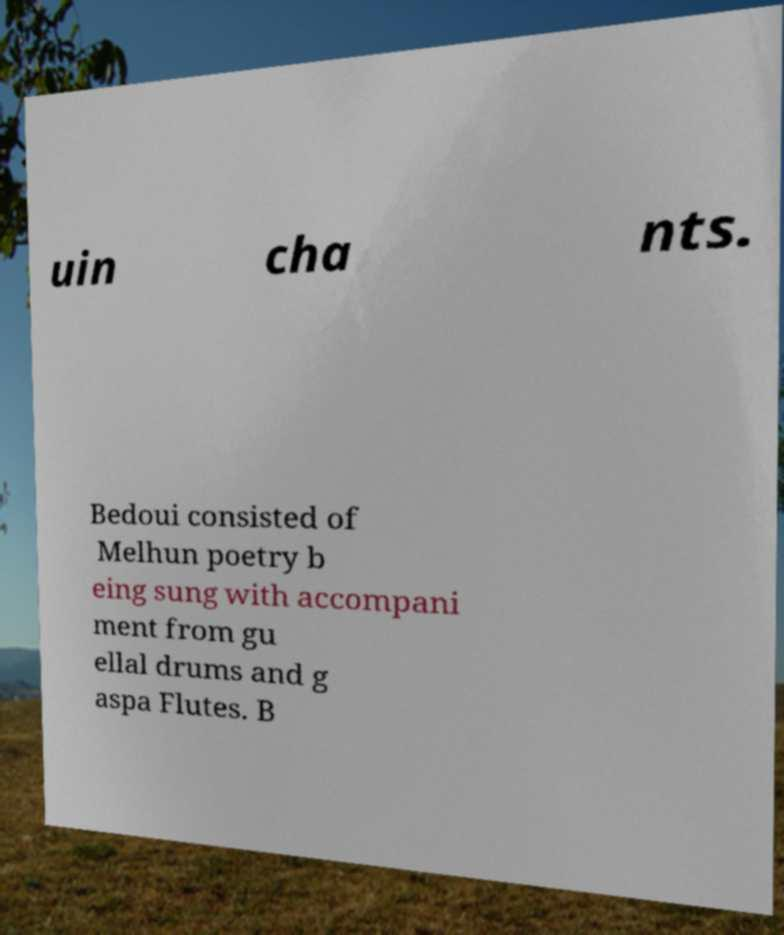Can you accurately transcribe the text from the provided image for me? uin cha nts. Bedoui consisted of Melhun poetry b eing sung with accompani ment from gu ellal drums and g aspa Flutes. B 